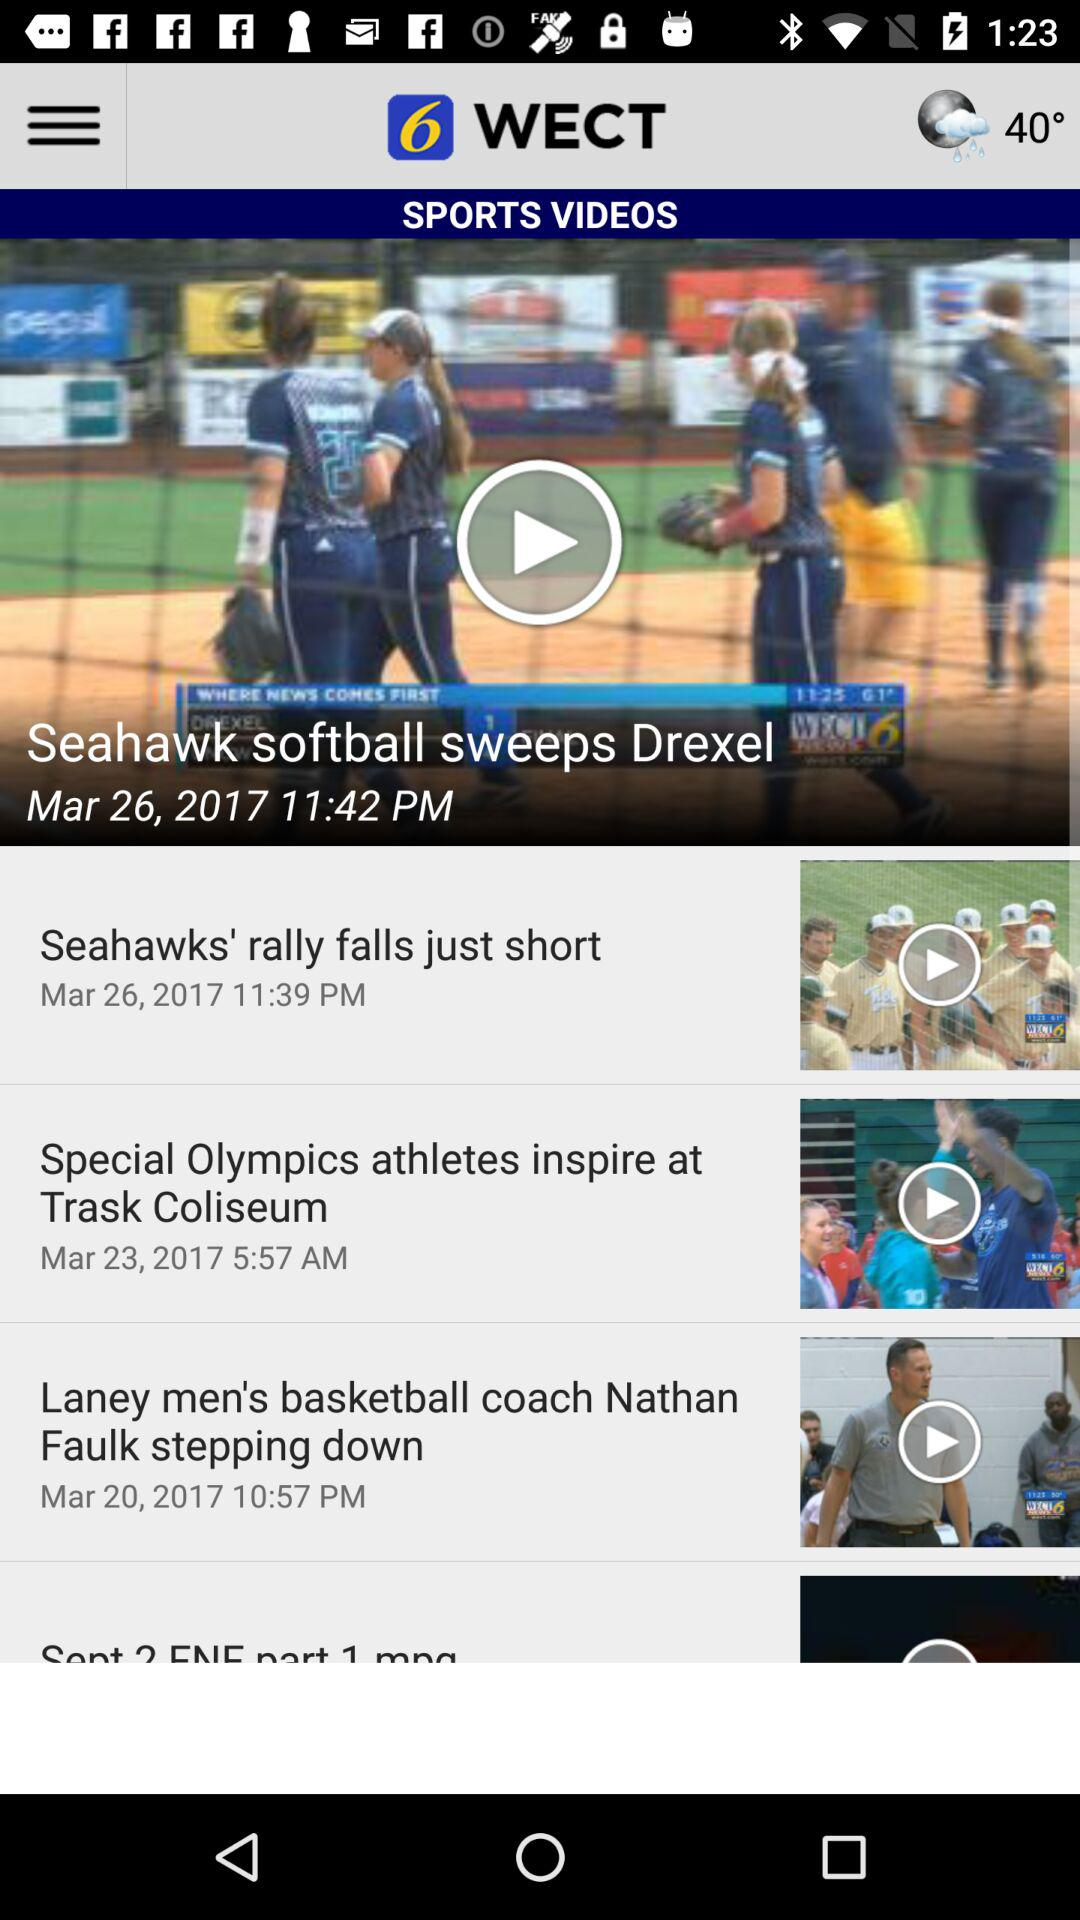What is the temperature? The temperature is 40 degrees. 